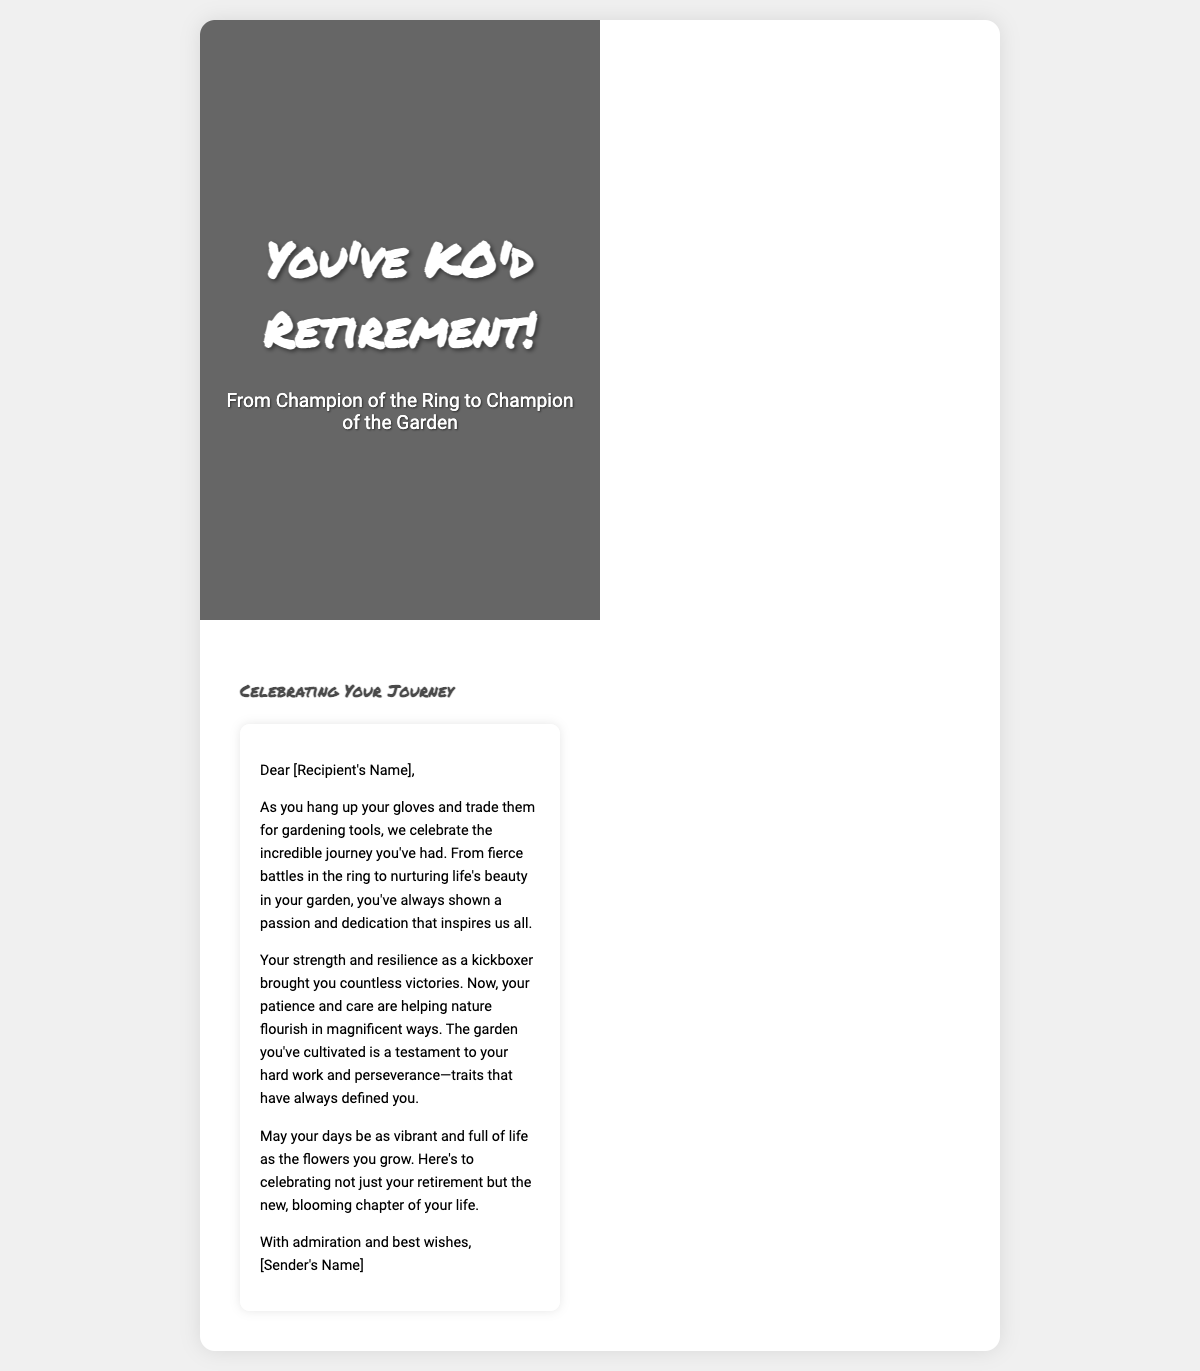What is the title of the card? The title of the card is prominently displayed on the front cover, which reads "You've KO'd Retirement!"
Answer: You've KO'd Retirement! What is featured on the front cover of the card? The front cover features a vintage photo of a knockout punch blended with blooming flowers.
Answer: Vintage photo and blooming flowers What is the main theme of the card? The theme of the card celebrates the transition from kickboxing to gardening, honoring both past and present passions.
Answer: Transition from kickboxing to gardening Who is the card addressed to? The greeting card addresses the recipient with "Dear [Recipient's Name]."
Answer: [Recipient's Name] What is one characteristic of the recipient mentioned in the message? The message highlights the recipient's strength and resilience as a kickboxer, which brought them victories.
Answer: Strength and resilience What does the card wish for the recipient? The card expresses a wish for the recipient's days to be vibrant and full of life like the flowers they grow.
Answer: Vibrant and full of life What does the sender wish to celebrate? The sender wishes to celebrate not just the retirement, but the new chapter of the recipient's life in gardening.
Answer: New chapter of life What kind of tools does the recipient trade their gloves for? The recipient trades their gloves for gardening tools as indicated in the message.
Answer: Gardening tools What does the inside-right of the card contain? The inside-right of the card contains a heartfelt message celebrating the recipient's journey.
Answer: Heartfelt message 